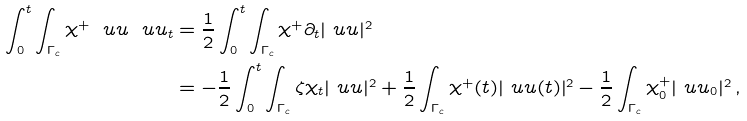Convert formula to latex. <formula><loc_0><loc_0><loc_500><loc_500>\int _ { 0 } ^ { t } \int _ { \Gamma _ { c } } \chi ^ { + } \ u u \ u u _ { t } & = \frac { 1 } { 2 } \int _ { 0 } ^ { t } \int _ { \Gamma _ { c } } \chi ^ { + } \partial _ { t } | \ u u | ^ { 2 } \\ & = - \frac { 1 } { 2 } \int _ { 0 } ^ { t } \int _ { \Gamma _ { c } } \zeta \chi _ { t } | \ u u | ^ { 2 } + \frac { 1 } { 2 } \int _ { \Gamma _ { c } } \chi ^ { + } ( t ) | \ u u ( t ) | ^ { 2 } - \frac { 1 } { 2 } \int _ { \Gamma _ { c } } \chi _ { 0 } ^ { + } | \ u u _ { 0 } | ^ { 2 } \, ,</formula> 